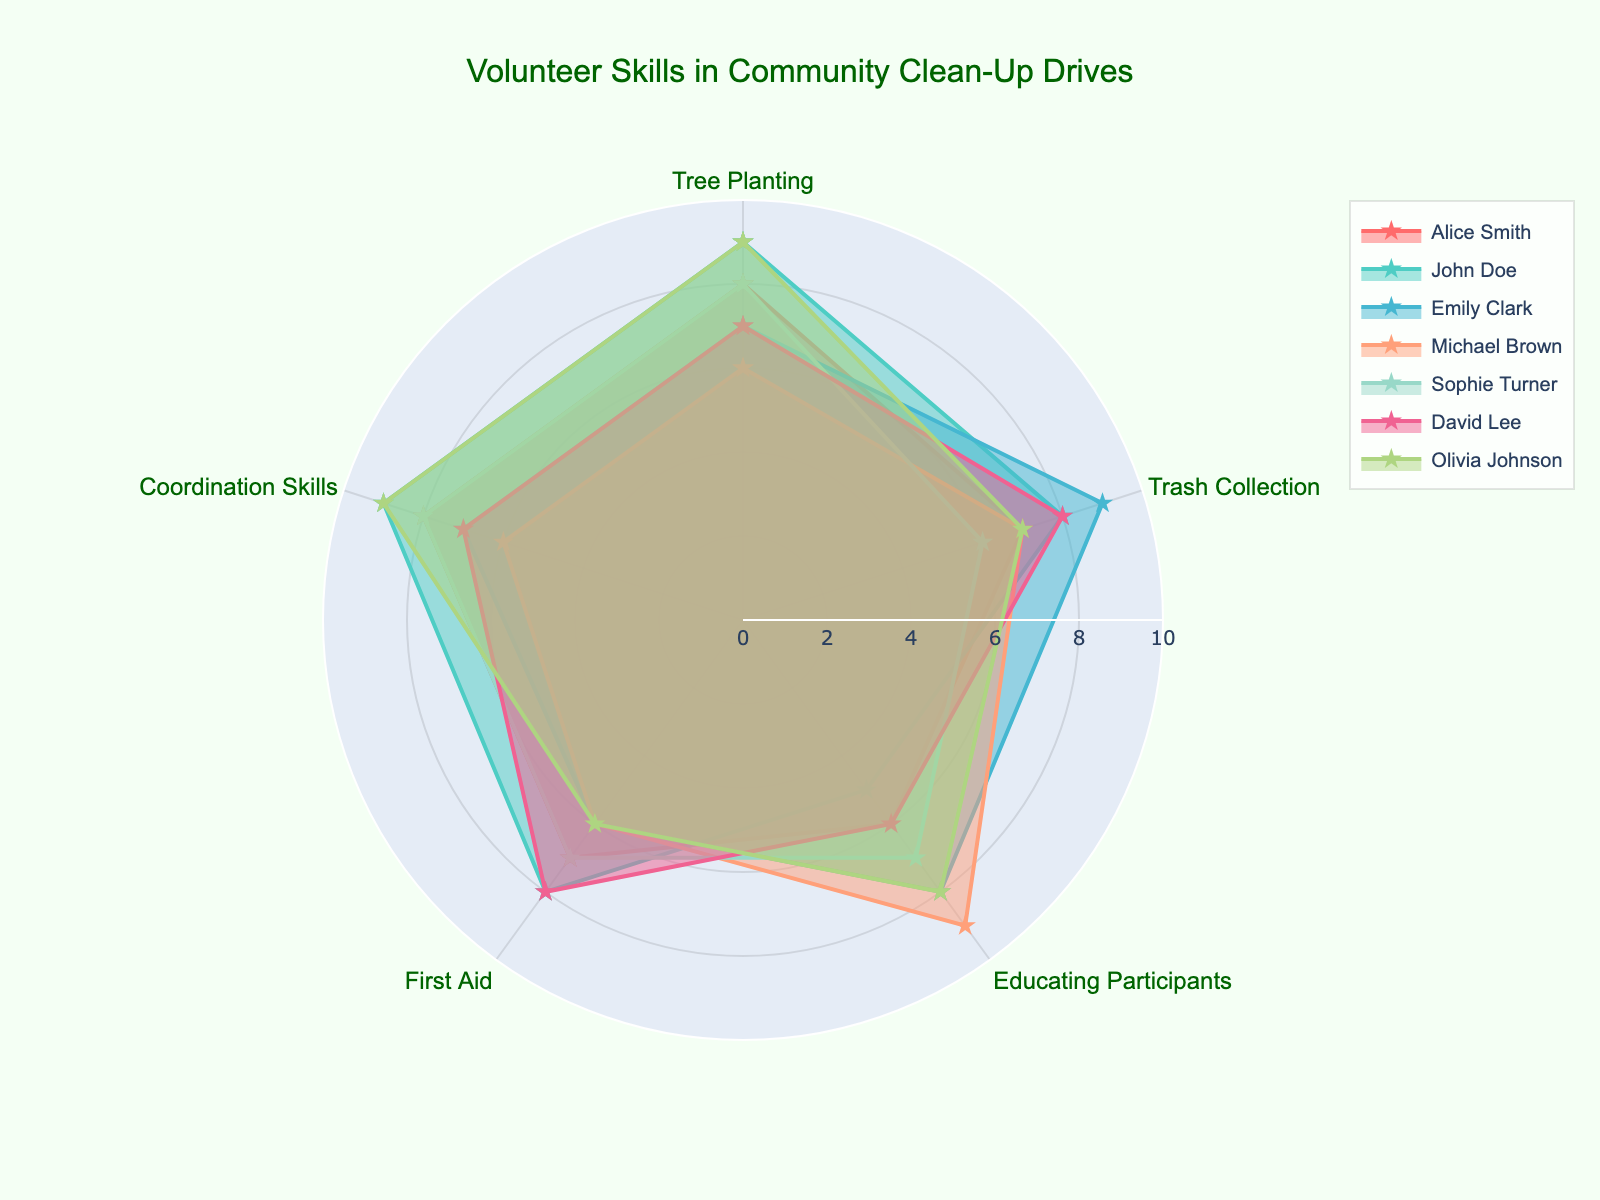What is the title of the radar chart? The title is usually displayed at the top center of the chart. It helps identify what the chart is about.
Answer: Volunteer Skills in Community Clean-Up Drives Which volunteer has the highest rating in First Aid? Look for the section labeled "First Aid" and see which volunteer has the highest value on this axis.
Answer: John Doe Which skill has the highest overall average rating across all volunteers? Calculate the average rating for each skill and compare them. The highest average value identifies the skill with the overall top rating.
Answer: Coordination Skills Between Alice Smith and Michael Brown, who has higher ratings in Trash Collection and how much higher? Check the values for "Trash Collection" for both Alice Smith and Michael Brown and compute the difference.
Answer: Alice Smith is higher by 1 point Who has the most balanced skill set across all categories? Look for the volunteer whose ratings do not vary much across different skills. This can be visually identified by a shape closer to a regular polygon.
Answer: Sophie Turner What is the combined score of Olivia Johnson in Educating Participants and Coordination Skills? Add the values of Olivia Johnson's ratings in "Educating Participants" and "Coordination Skills".
Answer: 17 Compare the skills of Emily Clark and David Lee in Tree Planting and First Aid. Who is more skilled in which area? Compare their individual ratings in "Tree Planting" and "First Aid".
Answer: Emily Clark is more skilled in Tree Planting; David Lee is more skilled in First Aid What are the maximum and minimum scores of Michael Brown across all skill categories? Identify the highest and lowest values in Michael Brown's ratings.
Answer: Maximum is 9, Minimum is 6 In which categories does Alice Smith score higher than John Doe? Compare Alice Smith’s and John Doe’s ratings for each skill category and identify where Alice scores higher.
Answer: Educating Participants What's the range of scores (difference between highest and lowest) for Sophie Turner in all skills? Find the highest and lowest scores for Sophie Turner and calculate the difference.
Answer: 2 